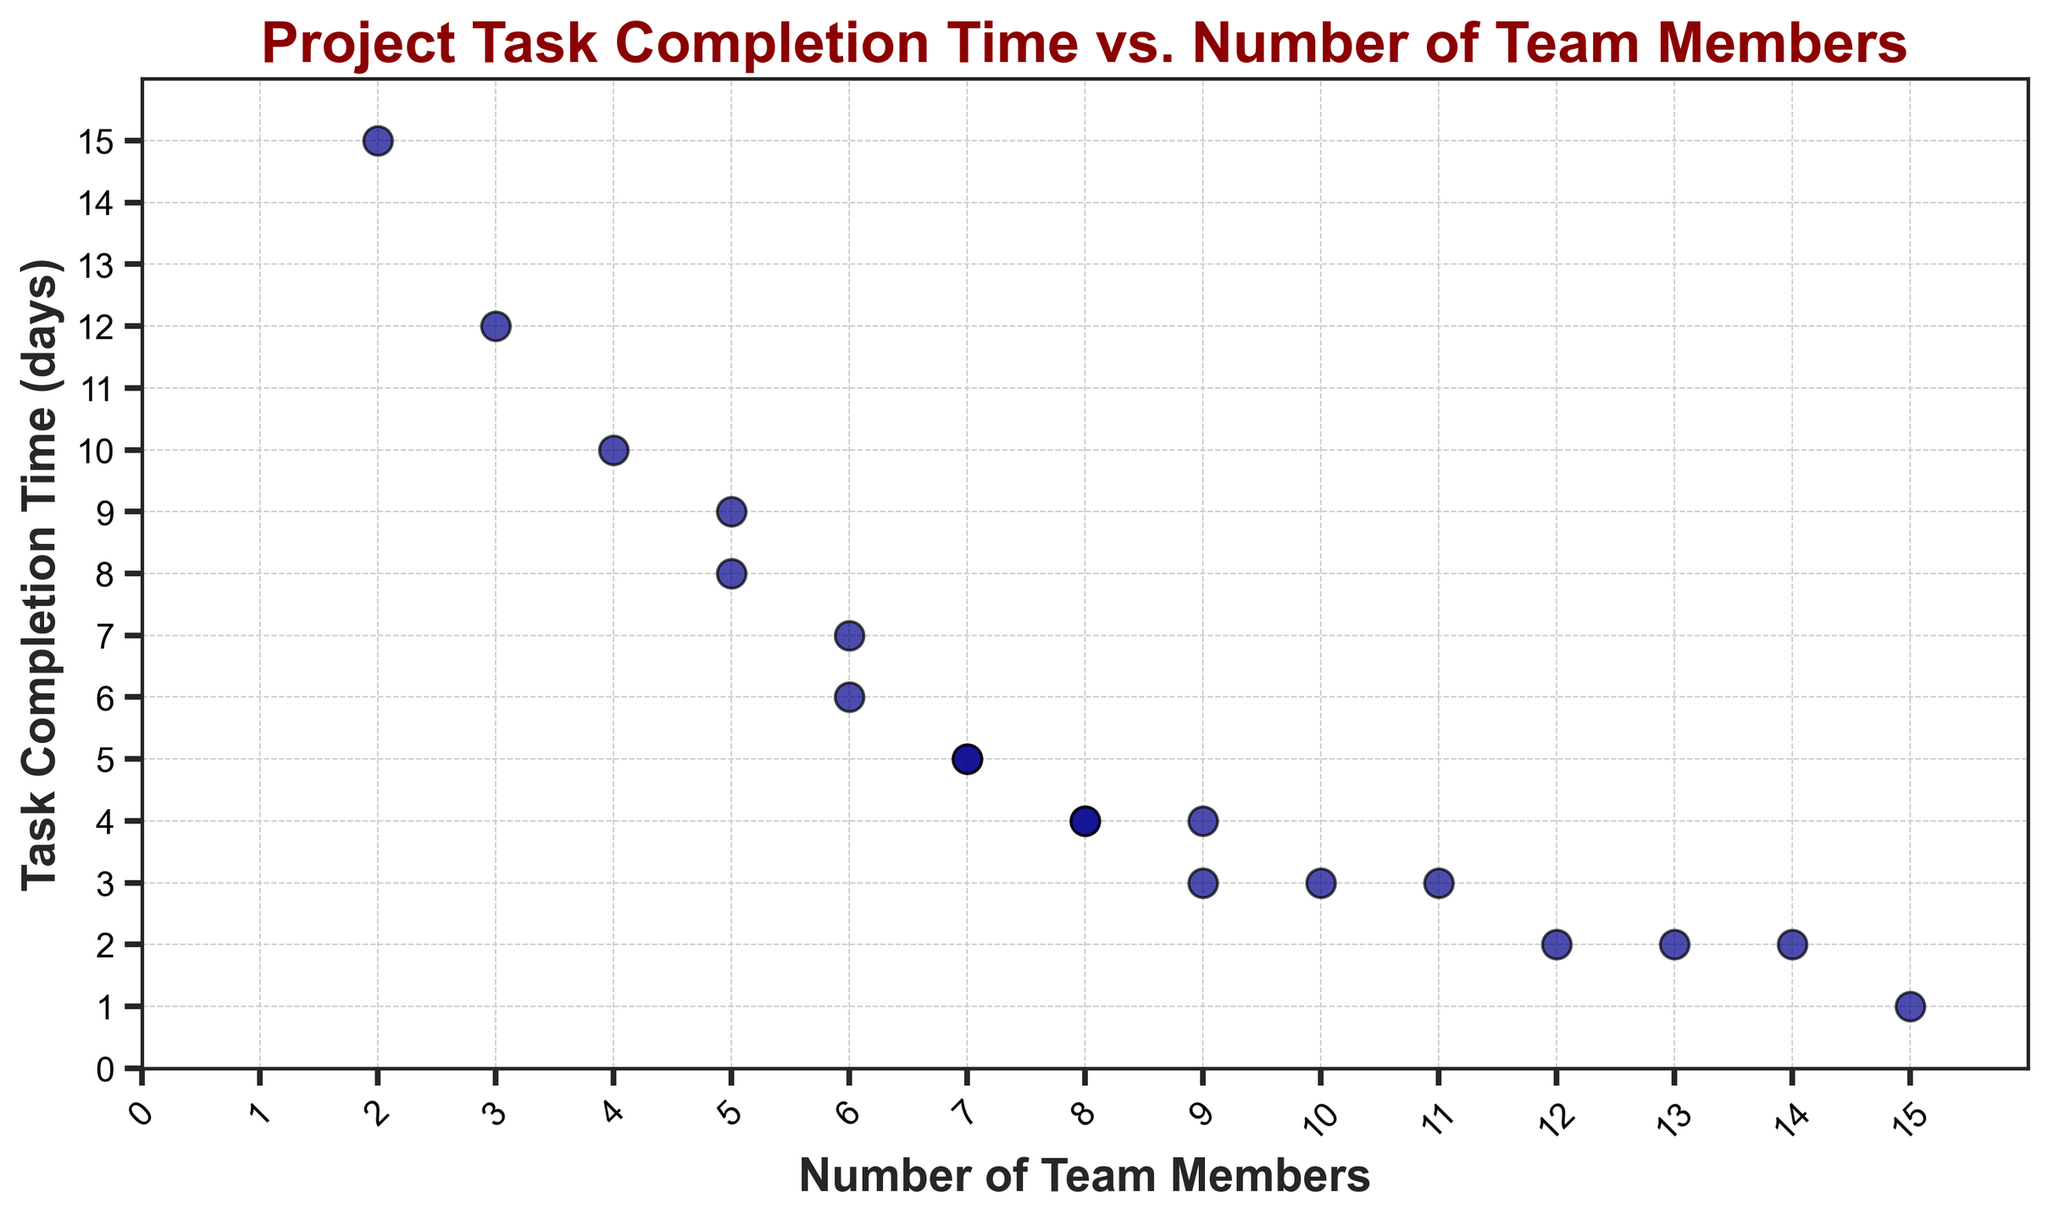What's the median task completion time when there are exactly 8 team members? To find the median task completion time for 8 team members, we look at the data points corresponding to 8 team members. The values are 4 and 4. Since there are only two values, the median is simply 4.
Answer: 4 What's the difference in task completion time between the teams with 9 and 2 members? The task completion time for 9 members is 3 and 4 days. For 2 members, it is 15 days. The average time for 9 members is (3+4)/2 = 3.5 days. The difference is 15 - 3.5 = 11.5 days.
Answer: 11.5 days Is there a team size where the task completion time is constant? By examining the scatter points, we can see that the task completion time for teams with 7, 8, 10, and 11 members is consistent. Both entries for 7, 8, 10, and 11 teams show the same time (5, 4, 3, and 3 days, respectively).
Answer: Yes How does the task completion time change as the number of team members increases from 5 to 6? For 5 members, the task completion times are 8 and 9 days. For 6 members, the times are 7 and 6 days. To find the average, for 5 members, it is (8+9)/2 = 8.5, and for 6 members, it is (7+6)/2 = 6.5. The change is 8.5 - 6.5 = 2 days.
Answer: Decreases by 2 days What is the average task completion time for team sizes greater than or equal to 10 members? For 10 members, the time is 3 days; for 11 members, 3 days; for 12 members, 2 days; for 13 members, 2 days; for 14 members, 2 days; and for 15 members, 1 day. The average is (3+3+2+2+2+1)/6 = 13/6 = 2.17 days.
Answer: 2.17 days Is there a significant drop in task completion time for any specific team size? By observing the plot, we see that the significant drops are between team sizes 2 and 5 members, where times drop from around 15 days to 9 days and again, between 6 and 7 members, where it drops from around 6 days to 5 days.
Answer: Yes Which team size results in the lowest task completion time? From the scatter plot, the lowest task completion time visible is for the team with 15 members, which is 1 day.
Answer: 15 members Between what range of team members is the task completion time constant at 2 days? By analyzing the plot, it is visible that the task completion time is 2 days for teams with 12, 13, and 14 members.
Answer: 12 to 14 members What is the total number of data points in the figure? Counting the number of scatter points in the plot, we find there are 19 data points, each representing a different team member count and corresponding task completion time.
Answer: 19 